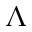<formula> <loc_0><loc_0><loc_500><loc_500>\Lambda</formula> 